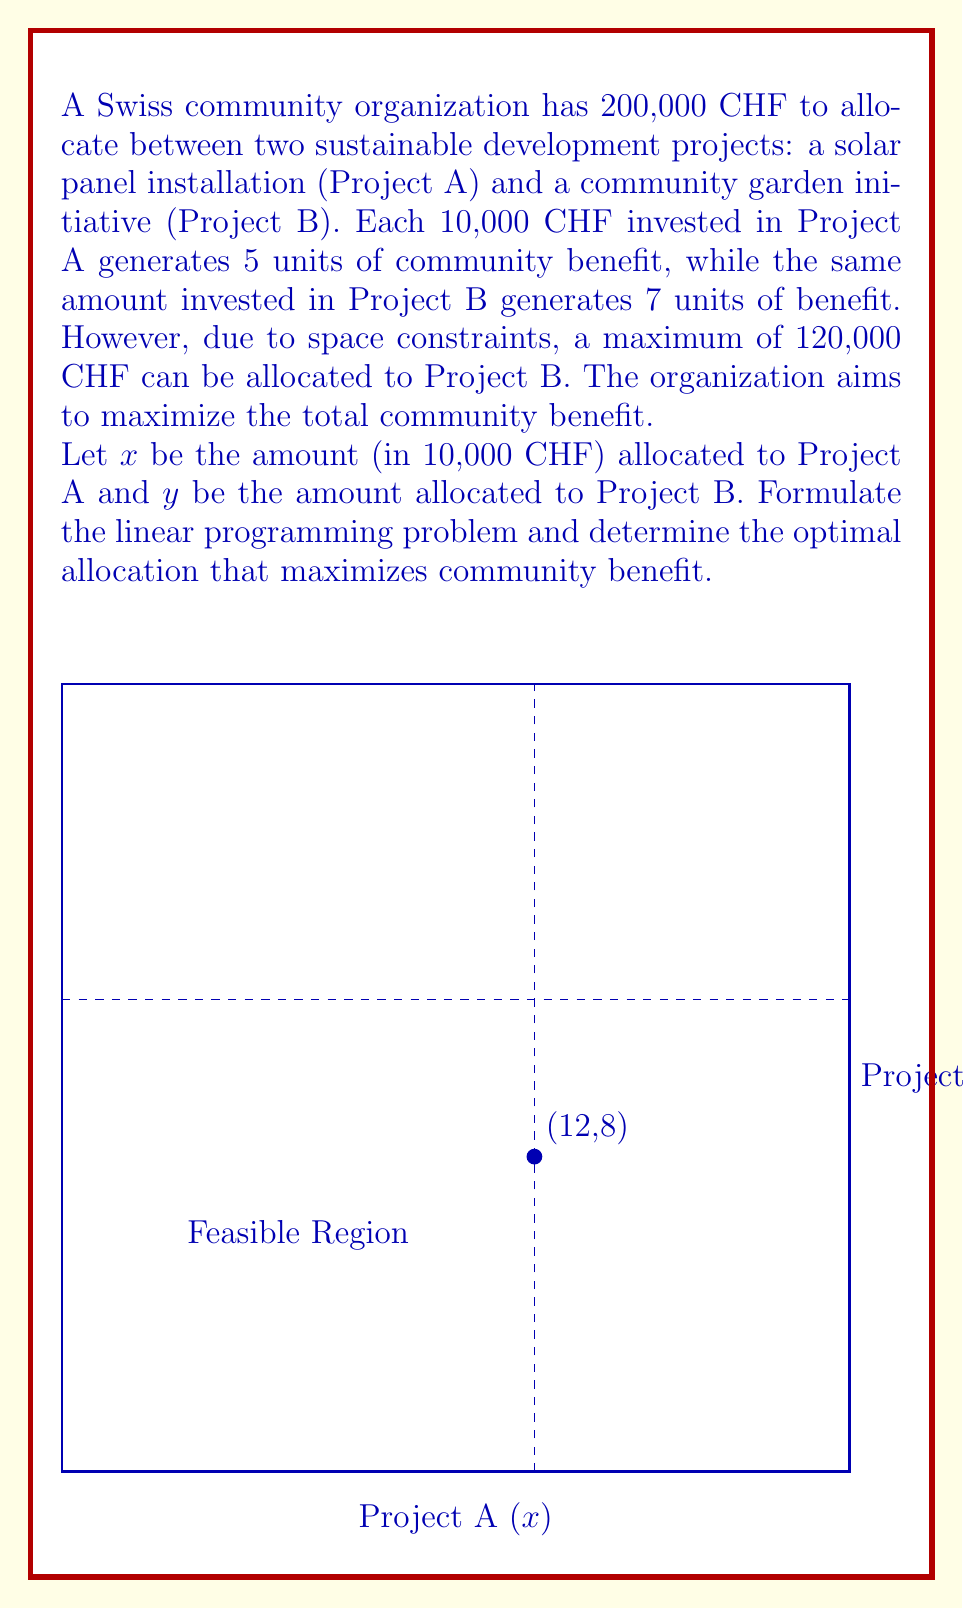Could you help me with this problem? Let's approach this step-by-step:

1) First, we need to set up the objective function. We want to maximize the total benefit:
   $$\text{Maximize } Z = 5x + 7y$$

2) Now, we need to establish the constraints:
   a) Total budget constraint: $x + y \leq 20$ (since 200,000 CHF = 20 * 10,000 CHF)
   b) Project B constraint: $y \leq 12$ (since 120,000 CHF = 12 * 10,000 CHF)
   c) Non-negativity constraints: $x \geq 0, y \geq 0$

3) The complete linear programming problem is:
   $$\text{Maximize } Z = 5x + 7y$$
   $$\text{Subject to:}$$
   $$x + y \leq 20$$
   $$y \leq 12$$
   $$x \geq 0, y \geq 0$$

4) To solve this, we can use the graphical method. The feasible region is bounded by the constraints, as shown in the figure.

5) The optimal solution will be at one of the corner points of the feasible region. The corner points are (0,0), (0,12), (8,12), and (20,0).

6) Evaluating the objective function at these points:
   At (0,0): Z = 0
   At (0,12): Z = 7(12) = 84
   At (8,12): Z = 5(8) + 7(12) = 124
   At (20,0): Z = 5(20) = 100

7) The maximum value of Z occurs at the point (8,12).

Therefore, the optimal allocation is to invest 80,000 CHF in Project A and 120,000 CHF in Project B.
Answer: Project A: 80,000 CHF, Project B: 120,000 CHF 